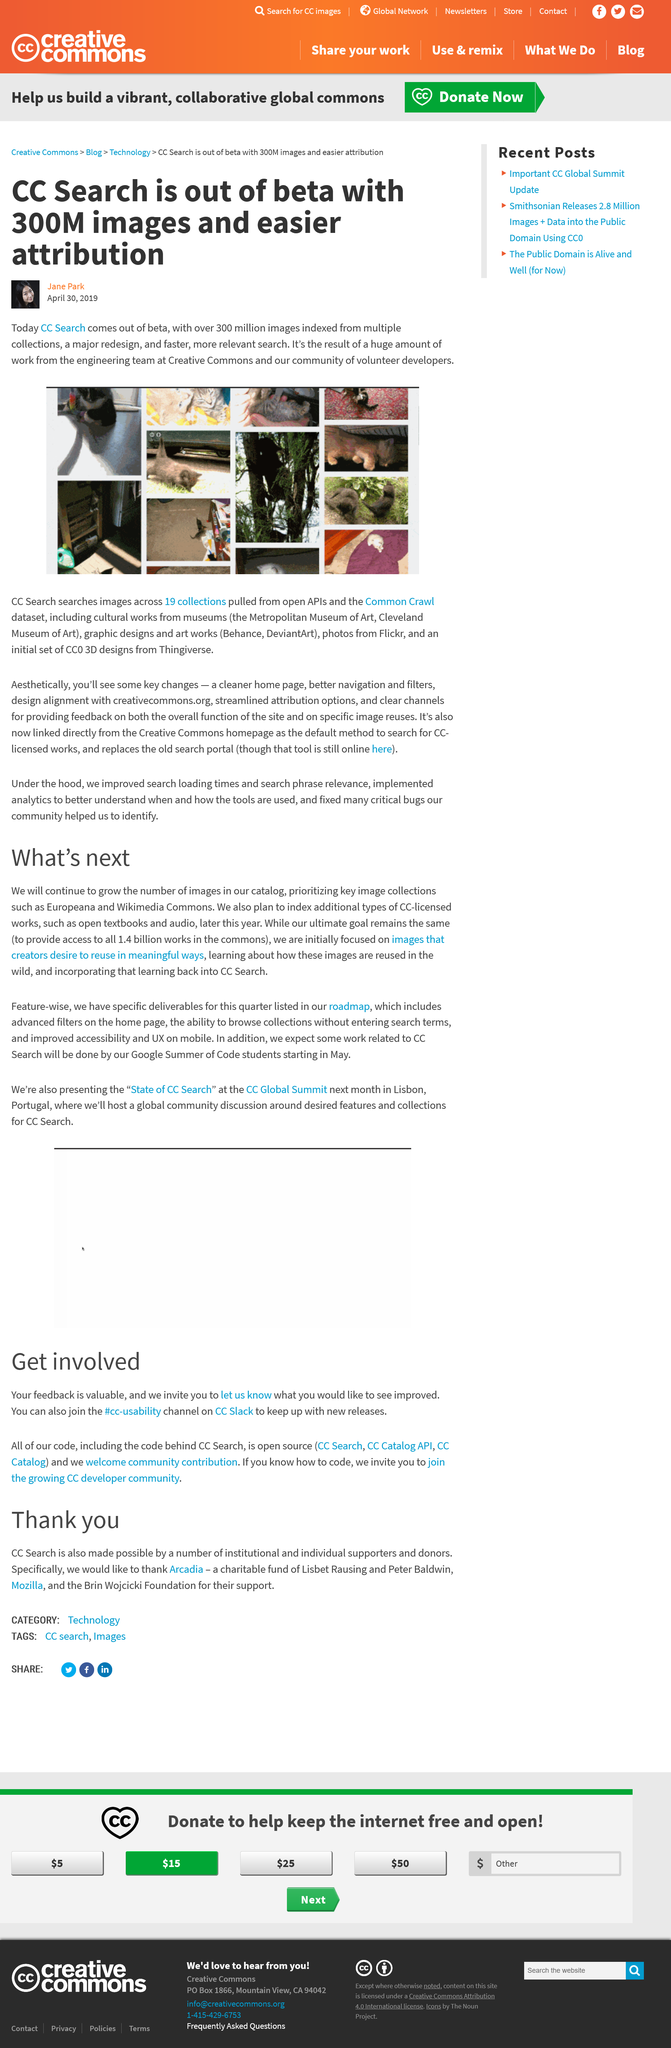Draw attention to some important aspects in this diagram. The ultimate goal is to provide access to all 1.4 billion works in the commons. CC searches images across 19 different collections. The words written in blue text are images that creators desire to reuse in meaningful ways, as outlined in the roadmap. Cc Search officially exited the beta phase on April 30th, 2019. There are 300 million images that the CC search has. 